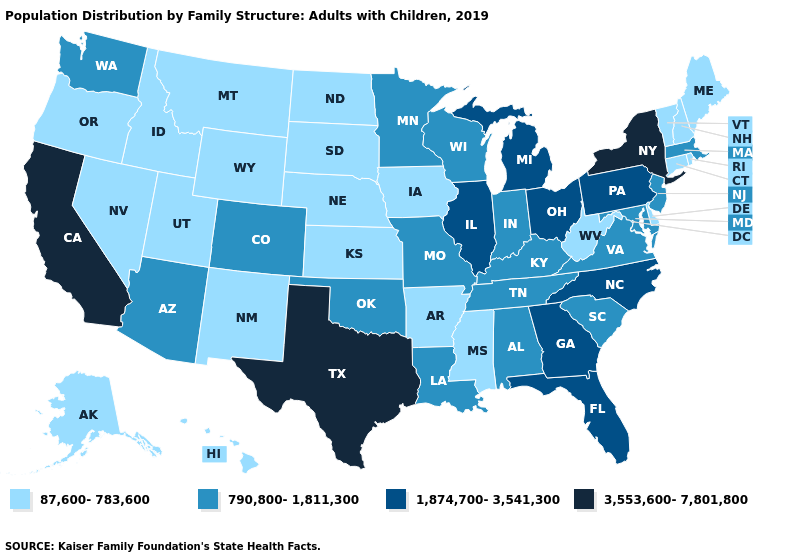Does South Carolina have a lower value than Kansas?
Be succinct. No. Name the states that have a value in the range 3,553,600-7,801,800?
Quick response, please. California, New York, Texas. What is the value of California?
Give a very brief answer. 3,553,600-7,801,800. What is the value of West Virginia?
Be succinct. 87,600-783,600. What is the value of Wyoming?
Short answer required. 87,600-783,600. What is the lowest value in the USA?
Keep it brief. 87,600-783,600. What is the value of Michigan?
Quick response, please. 1,874,700-3,541,300. Does Michigan have a lower value than New Mexico?
Write a very short answer. No. What is the value of Colorado?
Quick response, please. 790,800-1,811,300. Name the states that have a value in the range 87,600-783,600?
Concise answer only. Alaska, Arkansas, Connecticut, Delaware, Hawaii, Idaho, Iowa, Kansas, Maine, Mississippi, Montana, Nebraska, Nevada, New Hampshire, New Mexico, North Dakota, Oregon, Rhode Island, South Dakota, Utah, Vermont, West Virginia, Wyoming. How many symbols are there in the legend?
Keep it brief. 4. What is the value of Missouri?
Answer briefly. 790,800-1,811,300. What is the value of Colorado?
Short answer required. 790,800-1,811,300. What is the lowest value in the USA?
Concise answer only. 87,600-783,600. What is the lowest value in states that border Texas?
Concise answer only. 87,600-783,600. 